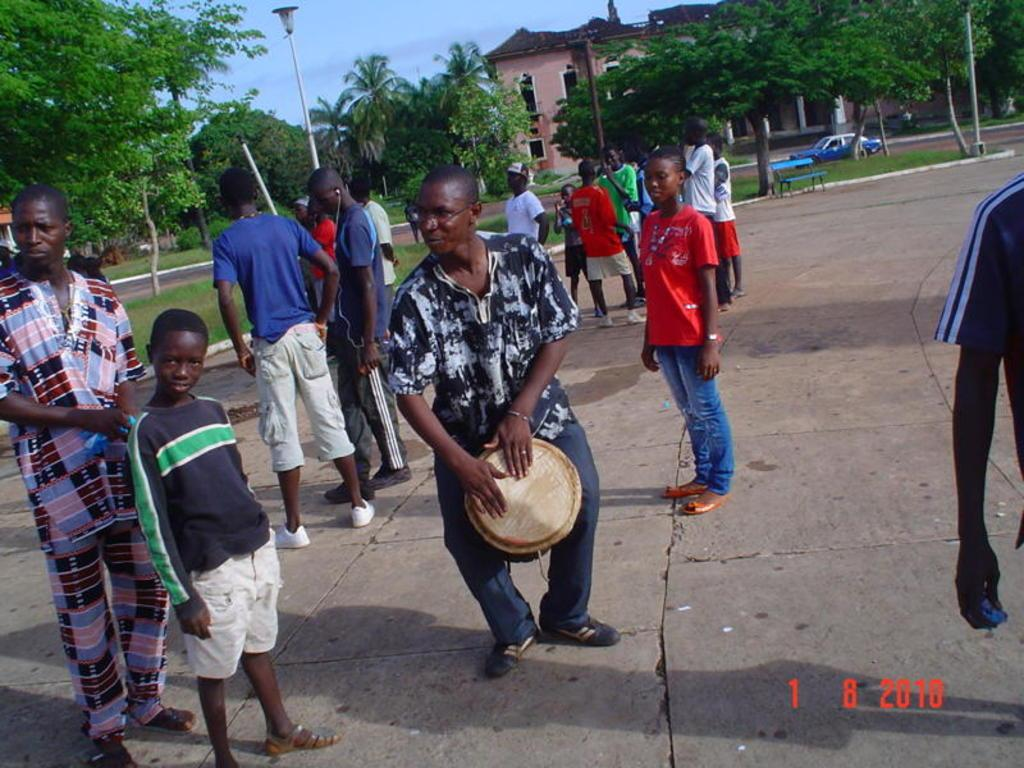What is happening in the image involving a group of people? There is a group of people standing in the image. What type of structure is present in the image? There is a house in the image. What can be seen around the house in the image? There are trees around the house in the image. What activity is a man engaged in within the image? A man is playing drums in the image. What type of vehicle is parked in the image? There is a car parked in the image. What type of sponge is being used to clean the roof in the image? There is no sponge or roof cleaning activity present in the image. What territory is being claimed by the group of people in the image? There is no indication of territory being claimed by the group of people in the image. 